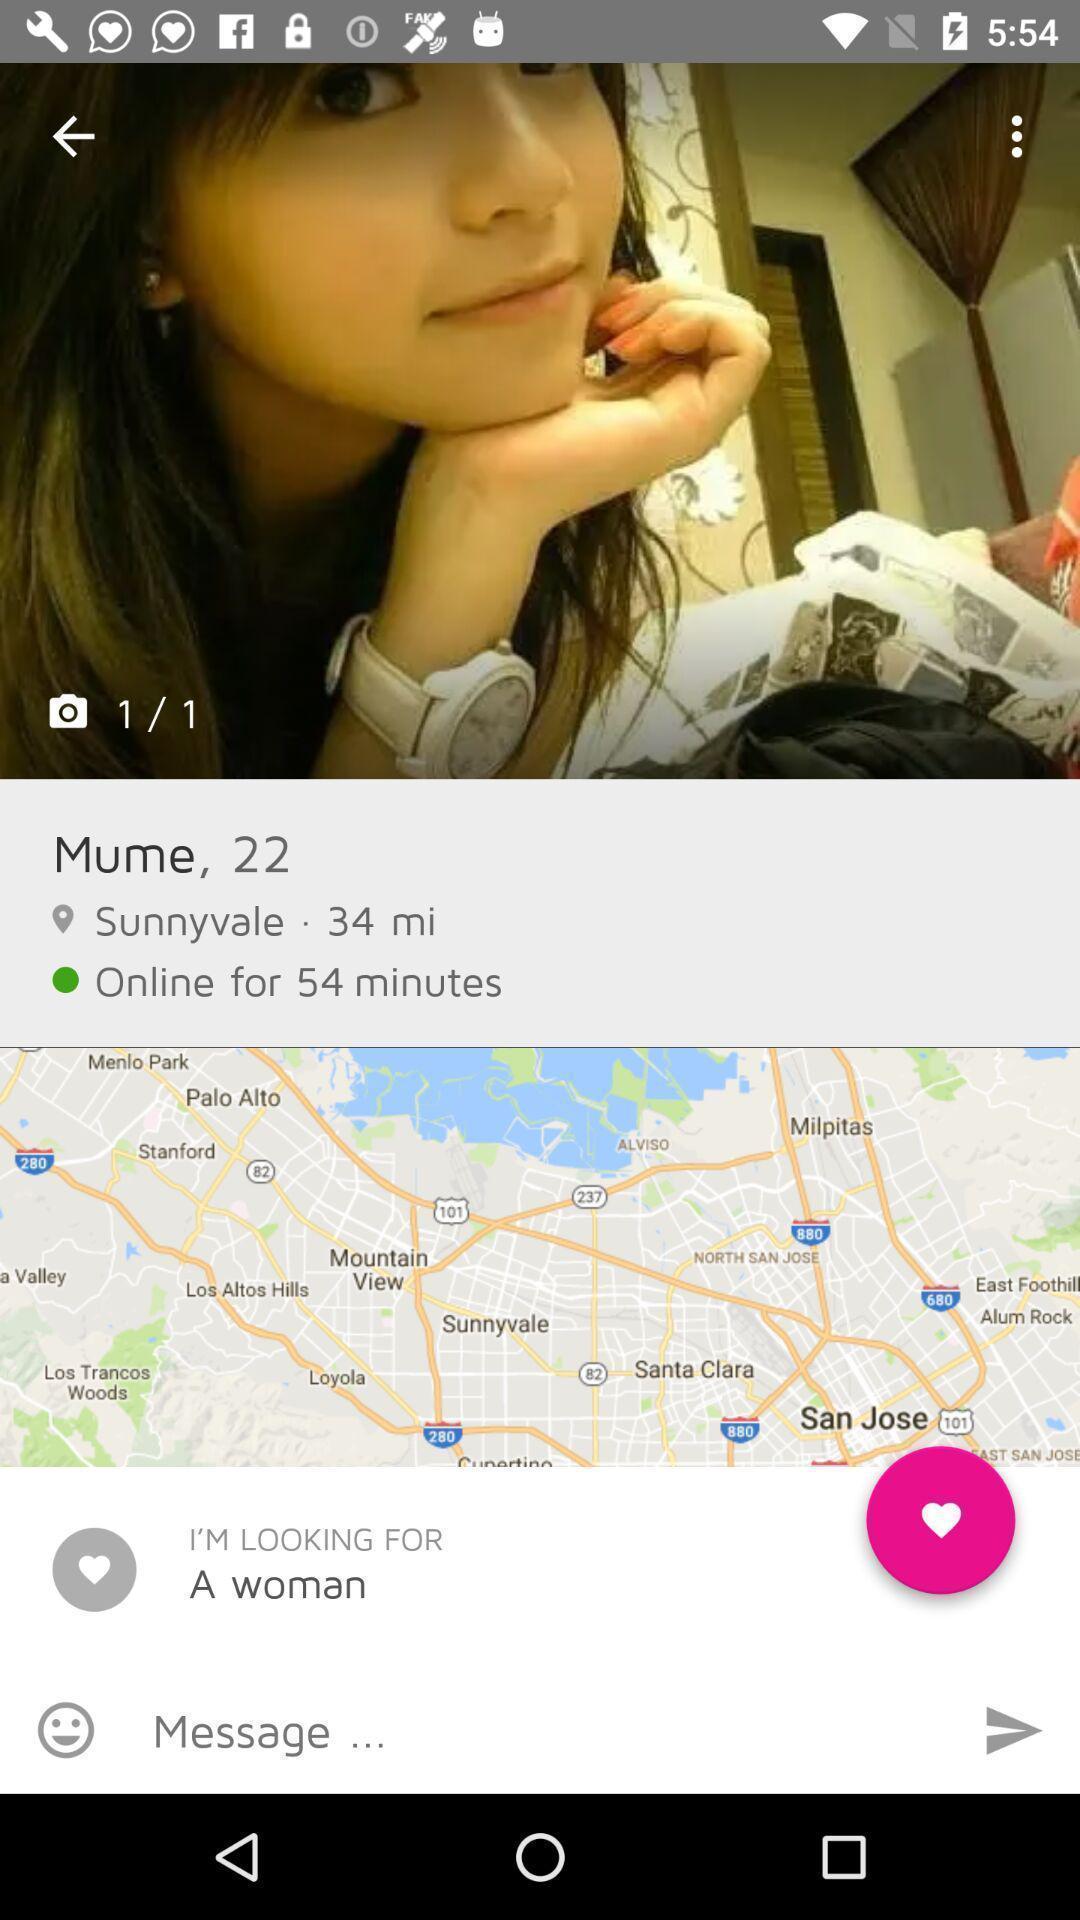Explain the elements present in this screenshot. Page showing profile information about one person. 